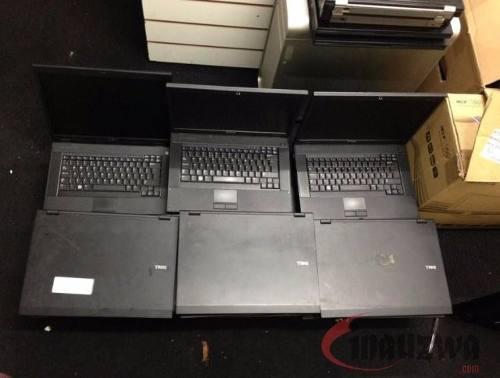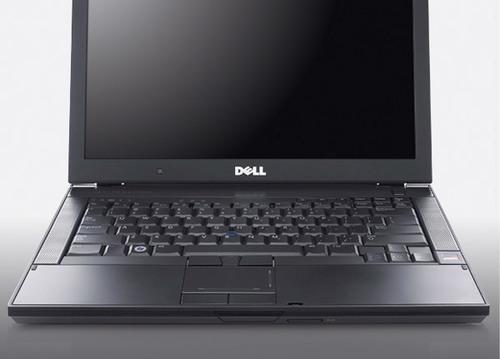The first image is the image on the left, the second image is the image on the right. Evaluate the accuracy of this statement regarding the images: "There are exactly five open laptops.". Is it true? Answer yes or no. No. The first image is the image on the left, the second image is the image on the right. For the images displayed, is the sentence "The left image shows laptops in horizontal rows of three and includes rows of open laptops and rows of closed laptops." factually correct? Answer yes or no. Yes. 